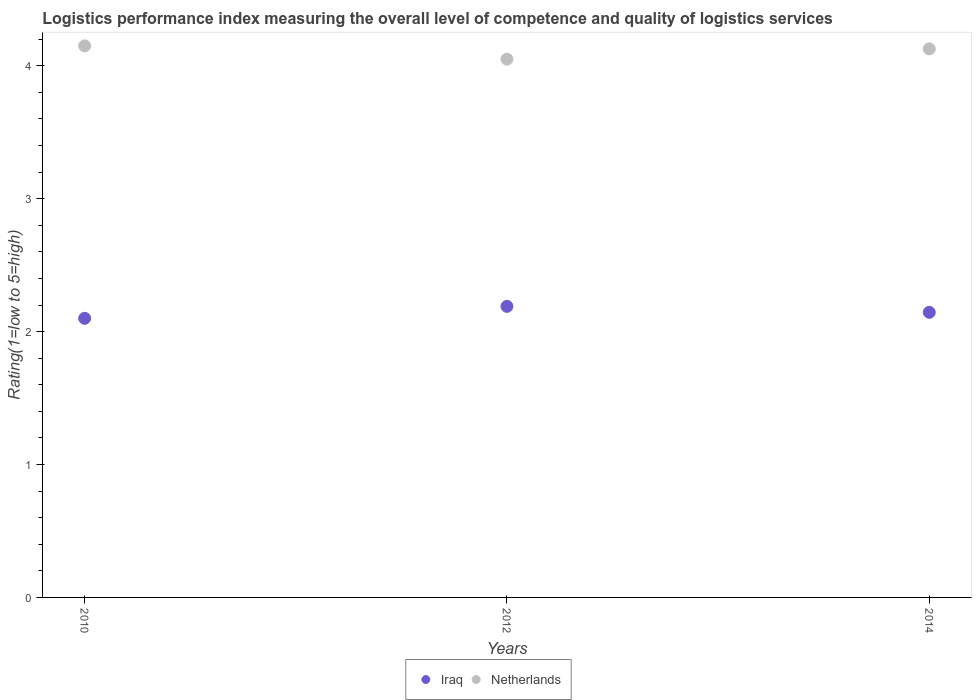How many different coloured dotlines are there?
Provide a short and direct response. 2. What is the Logistic performance index in Iraq in 2014?
Make the answer very short. 2.15. Across all years, what is the maximum Logistic performance index in Iraq?
Give a very brief answer. 2.19. Across all years, what is the minimum Logistic performance index in Netherlands?
Provide a succinct answer. 4.05. In which year was the Logistic performance index in Iraq maximum?
Provide a succinct answer. 2012. What is the total Logistic performance index in Netherlands in the graph?
Ensure brevity in your answer.  12.33. What is the difference between the Logistic performance index in Iraq in 2010 and that in 2014?
Offer a terse response. -0.05. What is the difference between the Logistic performance index in Netherlands in 2014 and the Logistic performance index in Iraq in 2010?
Make the answer very short. 2.03. What is the average Logistic performance index in Iraq per year?
Offer a terse response. 2.15. In the year 2014, what is the difference between the Logistic performance index in Iraq and Logistic performance index in Netherlands?
Keep it short and to the point. -1.98. What is the ratio of the Logistic performance index in Iraq in 2010 to that in 2012?
Your response must be concise. 0.96. What is the difference between the highest and the second highest Logistic performance index in Iraq?
Your response must be concise. 0.04. What is the difference between the highest and the lowest Logistic performance index in Netherlands?
Provide a succinct answer. 0.1. In how many years, is the Logistic performance index in Netherlands greater than the average Logistic performance index in Netherlands taken over all years?
Your answer should be compact. 2. Is the sum of the Logistic performance index in Netherlands in 2012 and 2014 greater than the maximum Logistic performance index in Iraq across all years?
Provide a succinct answer. Yes. Is the Logistic performance index in Netherlands strictly greater than the Logistic performance index in Iraq over the years?
Provide a succinct answer. Yes. Are the values on the major ticks of Y-axis written in scientific E-notation?
Provide a short and direct response. No. Does the graph contain any zero values?
Ensure brevity in your answer.  No. How many legend labels are there?
Give a very brief answer. 2. How are the legend labels stacked?
Ensure brevity in your answer.  Horizontal. What is the title of the graph?
Provide a succinct answer. Logistics performance index measuring the overall level of competence and quality of logistics services. What is the label or title of the Y-axis?
Give a very brief answer. Rating(1=low to 5=high). What is the Rating(1=low to 5=high) of Netherlands in 2010?
Your answer should be very brief. 4.15. What is the Rating(1=low to 5=high) in Iraq in 2012?
Make the answer very short. 2.19. What is the Rating(1=low to 5=high) of Netherlands in 2012?
Give a very brief answer. 4.05. What is the Rating(1=low to 5=high) of Iraq in 2014?
Ensure brevity in your answer.  2.15. What is the Rating(1=low to 5=high) of Netherlands in 2014?
Keep it short and to the point. 4.13. Across all years, what is the maximum Rating(1=low to 5=high) of Iraq?
Provide a succinct answer. 2.19. Across all years, what is the maximum Rating(1=low to 5=high) of Netherlands?
Offer a very short reply. 4.15. Across all years, what is the minimum Rating(1=low to 5=high) in Iraq?
Offer a very short reply. 2.1. Across all years, what is the minimum Rating(1=low to 5=high) in Netherlands?
Keep it short and to the point. 4.05. What is the total Rating(1=low to 5=high) in Iraq in the graph?
Your answer should be very brief. 6.44. What is the total Rating(1=low to 5=high) of Netherlands in the graph?
Ensure brevity in your answer.  12.33. What is the difference between the Rating(1=low to 5=high) in Iraq in 2010 and that in 2012?
Ensure brevity in your answer.  -0.09. What is the difference between the Rating(1=low to 5=high) of Netherlands in 2010 and that in 2012?
Offer a very short reply. 0.1. What is the difference between the Rating(1=low to 5=high) in Iraq in 2010 and that in 2014?
Offer a very short reply. -0.05. What is the difference between the Rating(1=low to 5=high) of Netherlands in 2010 and that in 2014?
Ensure brevity in your answer.  0.02. What is the difference between the Rating(1=low to 5=high) in Iraq in 2012 and that in 2014?
Keep it short and to the point. 0.04. What is the difference between the Rating(1=low to 5=high) of Netherlands in 2012 and that in 2014?
Your answer should be compact. -0.08. What is the difference between the Rating(1=low to 5=high) of Iraq in 2010 and the Rating(1=low to 5=high) of Netherlands in 2012?
Ensure brevity in your answer.  -1.95. What is the difference between the Rating(1=low to 5=high) in Iraq in 2010 and the Rating(1=low to 5=high) in Netherlands in 2014?
Make the answer very short. -2.03. What is the difference between the Rating(1=low to 5=high) of Iraq in 2012 and the Rating(1=low to 5=high) of Netherlands in 2014?
Offer a terse response. -1.94. What is the average Rating(1=low to 5=high) of Iraq per year?
Your answer should be compact. 2.15. What is the average Rating(1=low to 5=high) of Netherlands per year?
Provide a succinct answer. 4.11. In the year 2010, what is the difference between the Rating(1=low to 5=high) in Iraq and Rating(1=low to 5=high) in Netherlands?
Provide a succinct answer. -2.05. In the year 2012, what is the difference between the Rating(1=low to 5=high) of Iraq and Rating(1=low to 5=high) of Netherlands?
Make the answer very short. -1.86. In the year 2014, what is the difference between the Rating(1=low to 5=high) in Iraq and Rating(1=low to 5=high) in Netherlands?
Ensure brevity in your answer.  -1.98. What is the ratio of the Rating(1=low to 5=high) in Iraq in 2010 to that in 2012?
Provide a succinct answer. 0.96. What is the ratio of the Rating(1=low to 5=high) in Netherlands in 2010 to that in 2012?
Your answer should be compact. 1.02. What is the ratio of the Rating(1=low to 5=high) in Iraq in 2010 to that in 2014?
Offer a terse response. 0.98. What is the ratio of the Rating(1=low to 5=high) of Iraq in 2012 to that in 2014?
Make the answer very short. 1.02. What is the ratio of the Rating(1=low to 5=high) in Netherlands in 2012 to that in 2014?
Offer a very short reply. 0.98. What is the difference between the highest and the second highest Rating(1=low to 5=high) of Iraq?
Provide a short and direct response. 0.04. What is the difference between the highest and the second highest Rating(1=low to 5=high) in Netherlands?
Your answer should be very brief. 0.02. What is the difference between the highest and the lowest Rating(1=low to 5=high) of Iraq?
Make the answer very short. 0.09. 